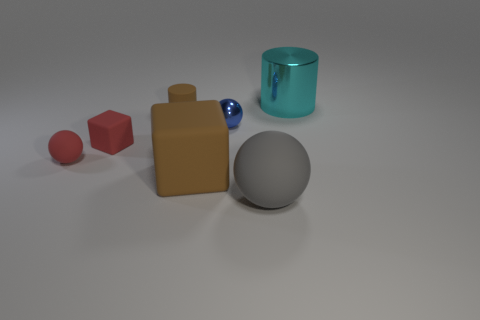The large matte thing to the left of the small sphere that is on the right side of the sphere on the left side of the big block is what color?
Keep it short and to the point. Brown. What number of other objects are there of the same color as the small cube?
Ensure brevity in your answer.  1. How many metallic things are gray things or tiny spheres?
Ensure brevity in your answer.  1. Does the matte object that is right of the tiny blue shiny thing have the same color as the small object left of the tiny red cube?
Offer a very short reply. No. Is there any other thing that is the same material as the large sphere?
Give a very brief answer. Yes. What is the size of the gray matte object that is the same shape as the small metal thing?
Make the answer very short. Large. Is the number of big brown blocks on the right side of the large brown rubber thing greater than the number of brown matte blocks?
Your answer should be compact. No. Are the cylinder that is left of the gray ball and the large brown thing made of the same material?
Give a very brief answer. Yes. There is a matte block in front of the small red rubber object that is behind the tiny ball left of the matte cylinder; what is its size?
Offer a very short reply. Large. What is the size of the red ball that is made of the same material as the brown cylinder?
Offer a very short reply. Small. 